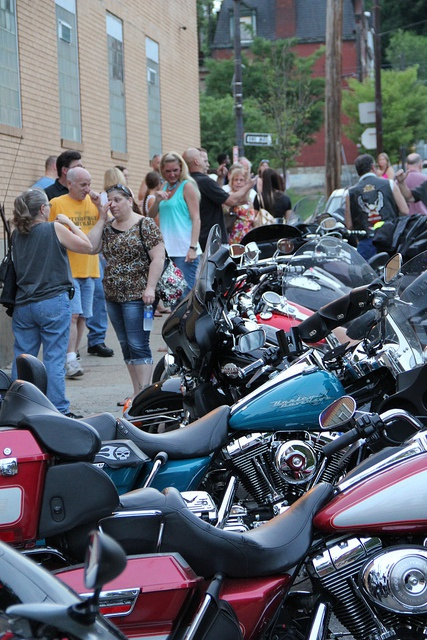Describe the objects in this image and their specific colors. I can see motorcycle in gray, black, and navy tones, people in gray, darkblue, and black tones, people in gray, black, darkgray, and navy tones, people in gray, tan, and darkgray tones, and people in gray, darkgray, and lightblue tones in this image. 